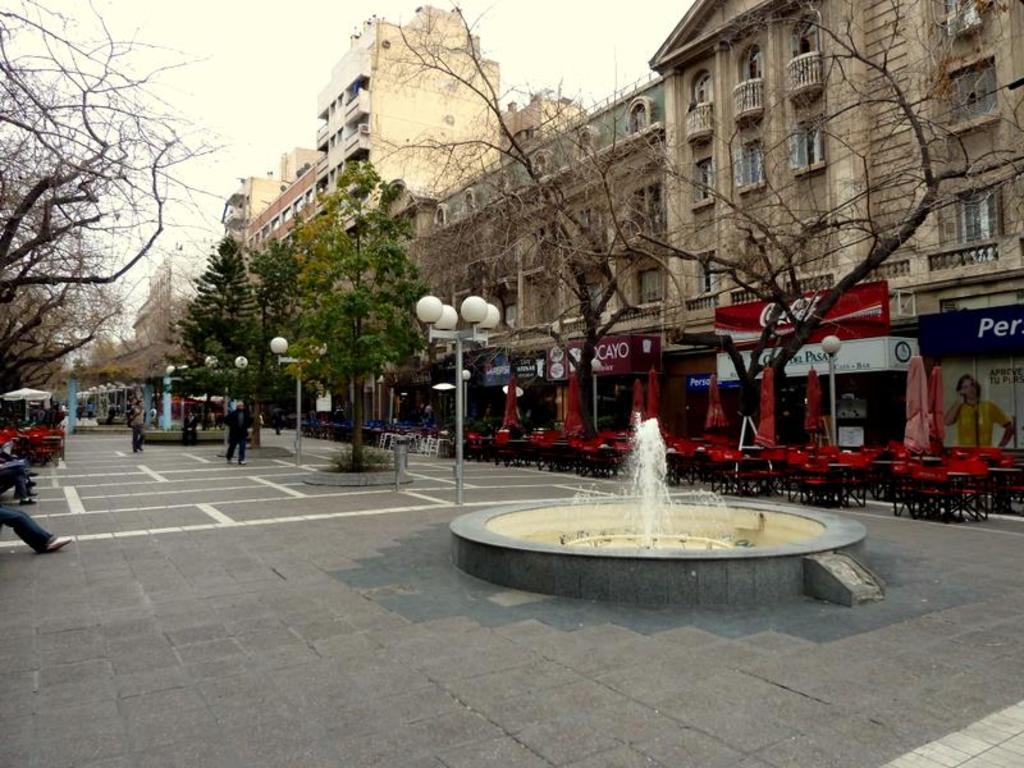How would you summarize this image in a sentence or two? In this picture there is a fountain and there are few trees and lights in front of it and there are few chairs,tables,dried trees and buildings in the right corner and there are few people and dried trees in the left corner. 